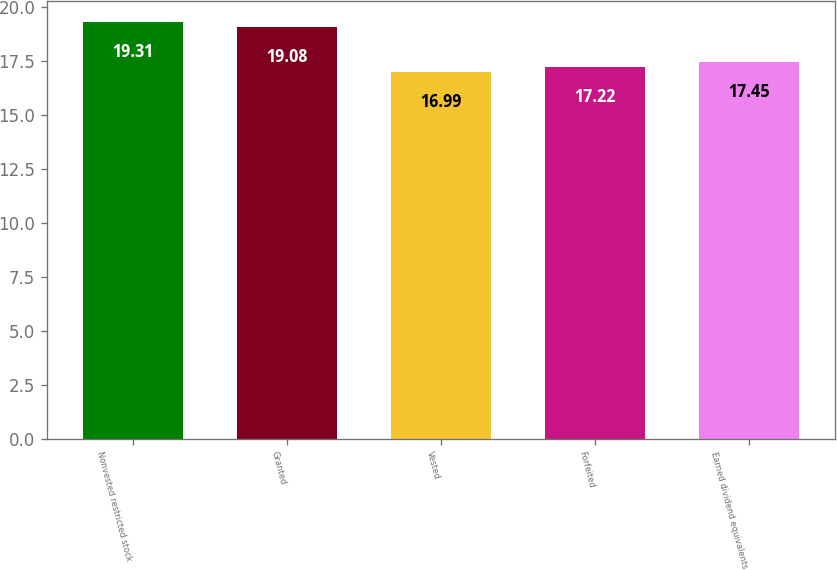Convert chart to OTSL. <chart><loc_0><loc_0><loc_500><loc_500><bar_chart><fcel>Nonvested restricted stock<fcel>Granted<fcel>Vested<fcel>Forfeited<fcel>Earned dividend equivalents<nl><fcel>19.31<fcel>19.08<fcel>16.99<fcel>17.22<fcel>17.45<nl></chart> 